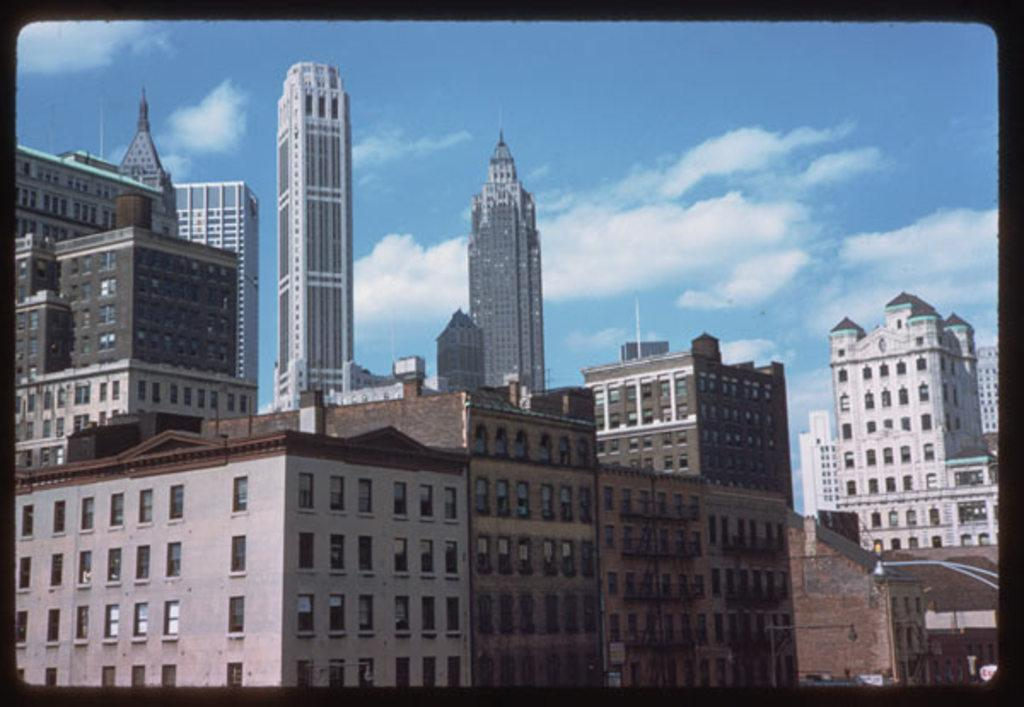What type of structures can be seen in the image? There are buildings in the image. Where is the light located in the image? The light is on the right side of the image. What is visible at the top of the image? The sky is visible at the top of the image. What can be observed in the sky? Clouds are present in the sky. Can you tell me how many police officers are visible in the image? There are no police officers present in the image. How can one join the town depicted in the image? The image does not depict a town, and therefore there is no information about joining it. 